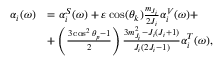Convert formula to latex. <formula><loc_0><loc_0><loc_500><loc_500>\begin{array} { r l } { \alpha _ { i } ( \omega ) } & { = \alpha _ { i } ^ { S } ( \omega ) + \varepsilon \cos ( \theta _ { k } ) \frac { m _ { J _ { i } } } { 2 J _ { i } } \alpha _ { i } ^ { V } ( \omega ) + } \\ & { + \left ( \frac { 3 \cos ^ { 2 } \theta _ { p } - 1 } { 2 } \right ) \frac { 3 m _ { J _ { i } } ^ { 2 } - J _ { i } ( J _ { i } + 1 ) } { J _ { i } ( 2 J _ { i } - 1 ) } \alpha _ { i } ^ { T } ( \omega ) , } \end{array}</formula> 